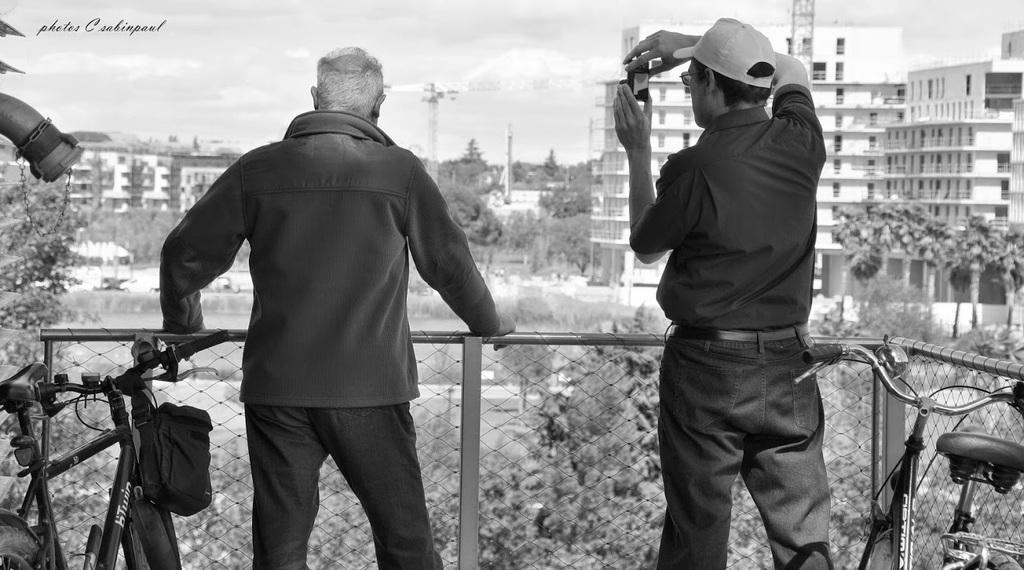Can you describe this image briefly? This picture is clicked outside. On the right we can see a person standing, holding a camera and seems to be taking pictures. On the left we can see another person standing and we can see a sling bag hanging on the bicycle and we can see the bicycles parked and we can see the mesh, metal rods, trees, buildings. In the background we can see the sky and many other objects. In the top left corner we can see the text on the image. 